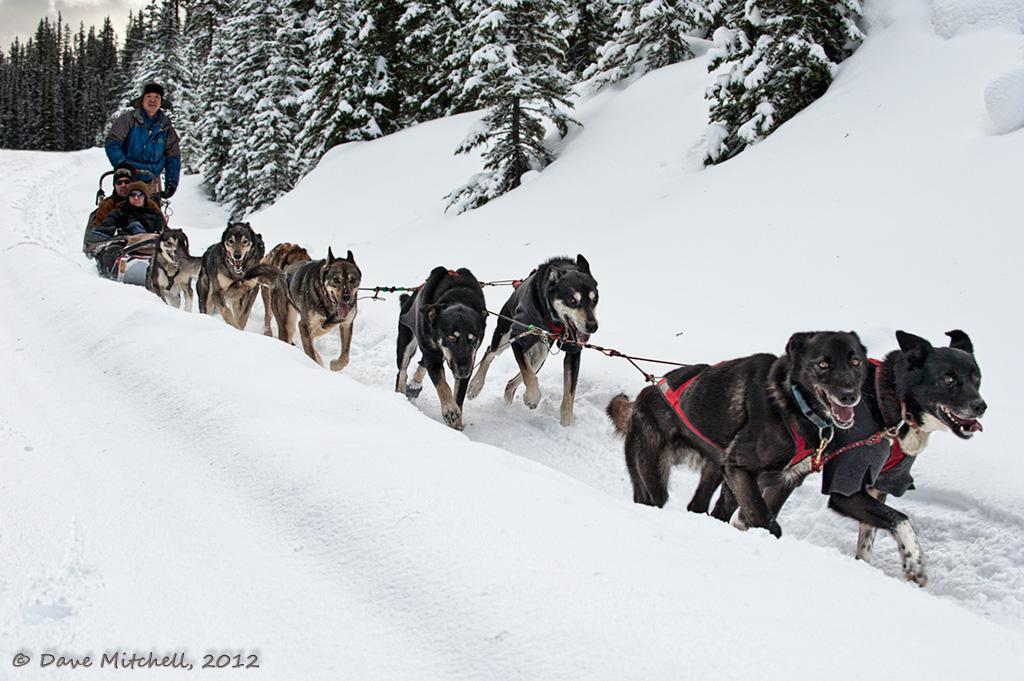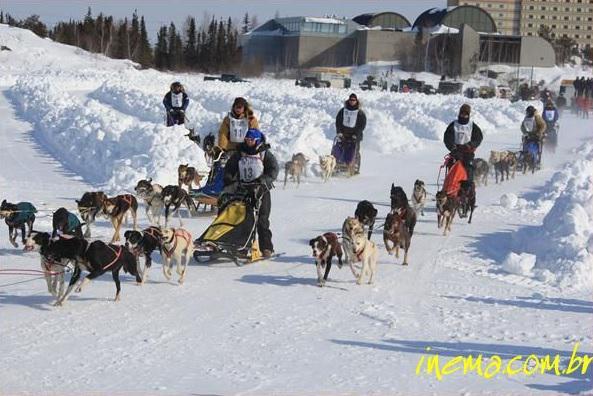The first image is the image on the left, the second image is the image on the right. Analyze the images presented: Is the assertion "There is at least one sled dog team pulling people on dog sleds through the snow." valid? Answer yes or no. Yes. 